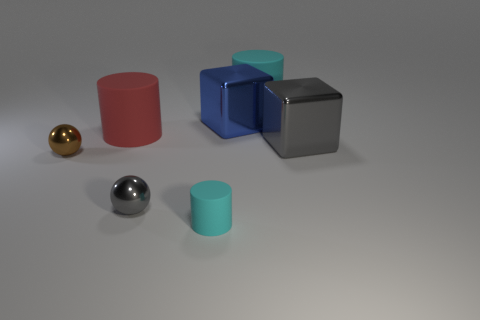Subtract all brown balls. Subtract all red cylinders. How many balls are left? 1 Add 1 purple rubber objects. How many objects exist? 8 Subtract all cubes. How many objects are left? 5 Subtract 0 cyan spheres. How many objects are left? 7 Subtract all rubber cylinders. Subtract all small gray metal objects. How many objects are left? 3 Add 1 big cyan rubber objects. How many big cyan rubber objects are left? 2 Add 3 cyan matte cylinders. How many cyan matte cylinders exist? 5 